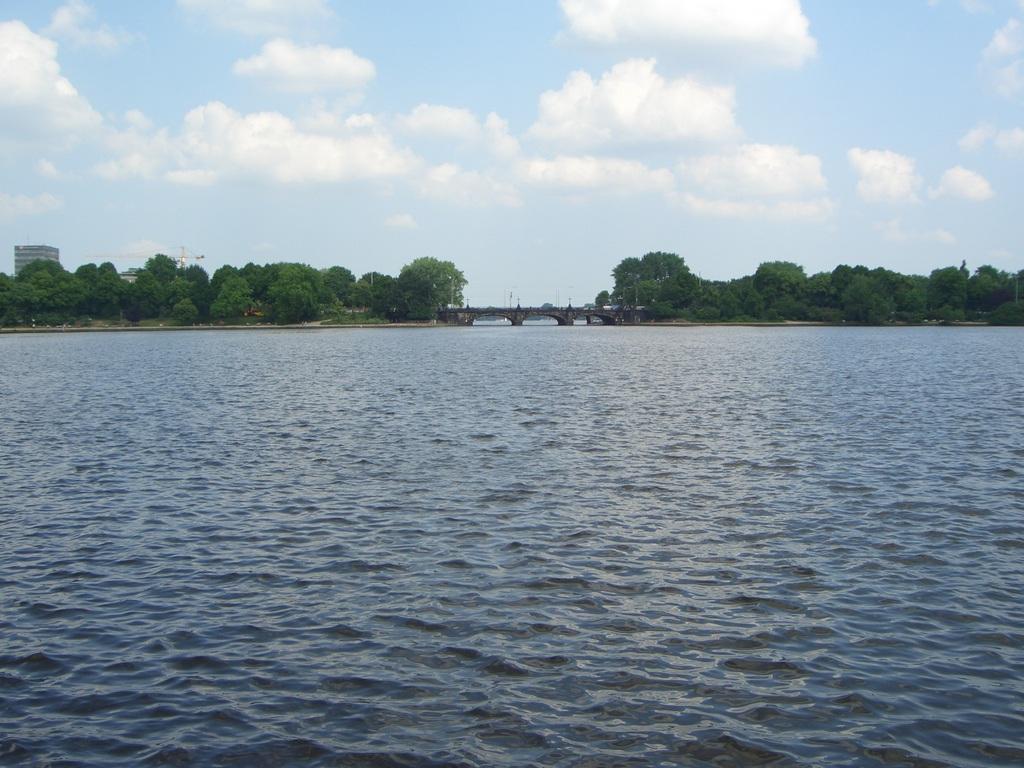Can you describe this image briefly? In this image, there is an outside view. In the foreground, there is a lake. There is a bridge and some trees in the middle of the image. In the background, there is a sky. 